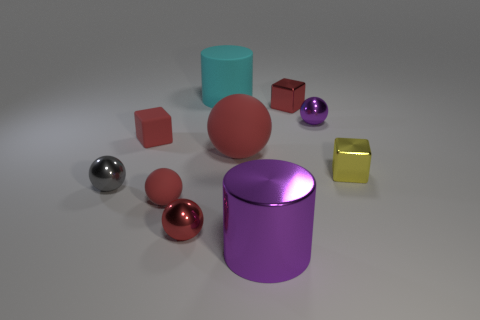What is the shape of the metallic thing that is the same color as the shiny cylinder?
Your answer should be compact. Sphere. What is the color of the rubber object that is the same size as the rubber block?
Provide a short and direct response. Red. What number of rubber things are tiny red cubes or tiny balls?
Your answer should be very brief. 2. How many tiny shiny objects are both on the right side of the small purple thing and to the left of the tiny red rubber sphere?
Your answer should be very brief. 0. Are there any other things that have the same shape as the tiny yellow thing?
Provide a short and direct response. Yes. What number of other things are the same size as the yellow metallic block?
Ensure brevity in your answer.  6. Is the size of the red shiny object that is right of the purple metallic cylinder the same as the cylinder in front of the large red rubber sphere?
Offer a terse response. No. What number of things are purple metallic things or red shiny objects that are behind the tiny purple sphere?
Offer a very short reply. 3. There is a red metallic object that is behind the purple shiny ball; how big is it?
Ensure brevity in your answer.  Small. Is the number of small cubes in front of the large purple metal cylinder less than the number of tiny red matte things in front of the big red ball?
Your answer should be very brief. Yes. 